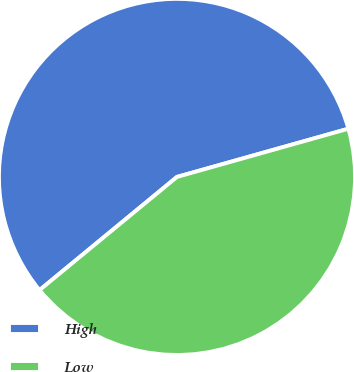<chart> <loc_0><loc_0><loc_500><loc_500><pie_chart><fcel>High<fcel>Low<nl><fcel>56.6%<fcel>43.4%<nl></chart> 